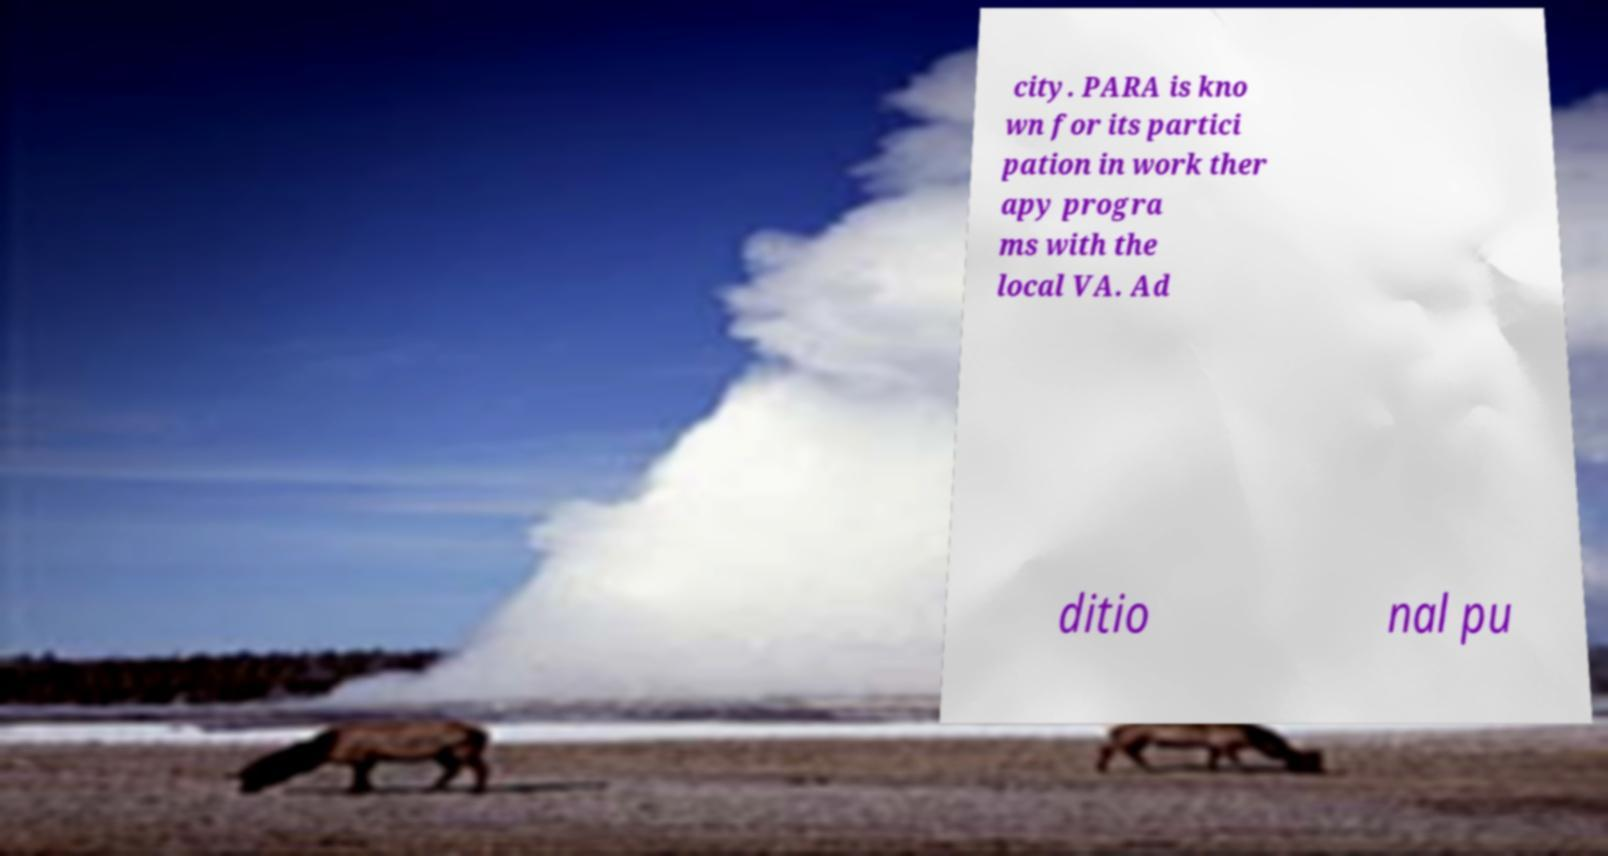Can you accurately transcribe the text from the provided image for me? city. PARA is kno wn for its partici pation in work ther apy progra ms with the local VA. Ad ditio nal pu 